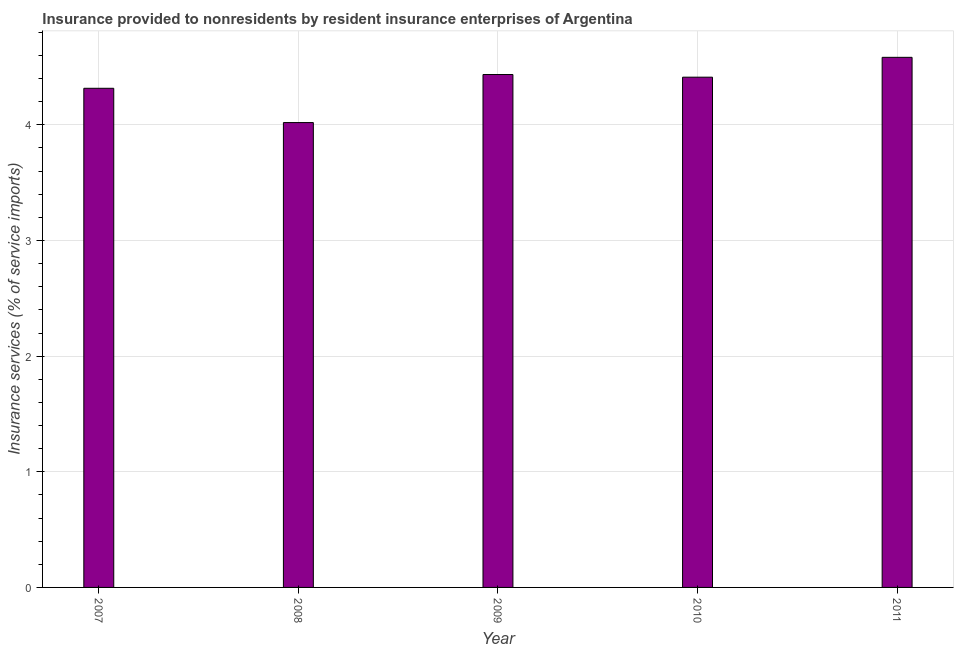Does the graph contain any zero values?
Offer a very short reply. No. What is the title of the graph?
Your answer should be very brief. Insurance provided to nonresidents by resident insurance enterprises of Argentina. What is the label or title of the X-axis?
Provide a succinct answer. Year. What is the label or title of the Y-axis?
Your response must be concise. Insurance services (% of service imports). What is the insurance and financial services in 2011?
Provide a short and direct response. 4.58. Across all years, what is the maximum insurance and financial services?
Give a very brief answer. 4.58. Across all years, what is the minimum insurance and financial services?
Your response must be concise. 4.02. In which year was the insurance and financial services maximum?
Make the answer very short. 2011. What is the sum of the insurance and financial services?
Ensure brevity in your answer.  21.77. What is the difference between the insurance and financial services in 2008 and 2009?
Your response must be concise. -0.42. What is the average insurance and financial services per year?
Keep it short and to the point. 4.35. What is the median insurance and financial services?
Ensure brevity in your answer.  4.41. Do a majority of the years between 2011 and 2010 (inclusive) have insurance and financial services greater than 0.8 %?
Offer a very short reply. No. What is the ratio of the insurance and financial services in 2008 to that in 2010?
Offer a terse response. 0.91. Is the insurance and financial services in 2008 less than that in 2011?
Keep it short and to the point. Yes. Is the difference between the insurance and financial services in 2009 and 2011 greater than the difference between any two years?
Offer a very short reply. No. What is the difference between the highest and the second highest insurance and financial services?
Keep it short and to the point. 0.15. Is the sum of the insurance and financial services in 2007 and 2009 greater than the maximum insurance and financial services across all years?
Ensure brevity in your answer.  Yes. What is the difference between the highest and the lowest insurance and financial services?
Provide a succinct answer. 0.56. Are all the bars in the graph horizontal?
Offer a terse response. No. How many years are there in the graph?
Ensure brevity in your answer.  5. Are the values on the major ticks of Y-axis written in scientific E-notation?
Offer a very short reply. No. What is the Insurance services (% of service imports) in 2007?
Your answer should be very brief. 4.32. What is the Insurance services (% of service imports) in 2008?
Keep it short and to the point. 4.02. What is the Insurance services (% of service imports) in 2009?
Ensure brevity in your answer.  4.44. What is the Insurance services (% of service imports) of 2010?
Ensure brevity in your answer.  4.41. What is the Insurance services (% of service imports) of 2011?
Make the answer very short. 4.58. What is the difference between the Insurance services (% of service imports) in 2007 and 2008?
Give a very brief answer. 0.3. What is the difference between the Insurance services (% of service imports) in 2007 and 2009?
Your answer should be compact. -0.12. What is the difference between the Insurance services (% of service imports) in 2007 and 2010?
Make the answer very short. -0.1. What is the difference between the Insurance services (% of service imports) in 2007 and 2011?
Provide a succinct answer. -0.27. What is the difference between the Insurance services (% of service imports) in 2008 and 2009?
Offer a very short reply. -0.42. What is the difference between the Insurance services (% of service imports) in 2008 and 2010?
Ensure brevity in your answer.  -0.39. What is the difference between the Insurance services (% of service imports) in 2008 and 2011?
Your response must be concise. -0.56. What is the difference between the Insurance services (% of service imports) in 2009 and 2010?
Offer a very short reply. 0.02. What is the difference between the Insurance services (% of service imports) in 2009 and 2011?
Ensure brevity in your answer.  -0.15. What is the difference between the Insurance services (% of service imports) in 2010 and 2011?
Ensure brevity in your answer.  -0.17. What is the ratio of the Insurance services (% of service imports) in 2007 to that in 2008?
Provide a short and direct response. 1.07. What is the ratio of the Insurance services (% of service imports) in 2007 to that in 2011?
Offer a terse response. 0.94. What is the ratio of the Insurance services (% of service imports) in 2008 to that in 2009?
Your response must be concise. 0.91. What is the ratio of the Insurance services (% of service imports) in 2008 to that in 2010?
Give a very brief answer. 0.91. What is the ratio of the Insurance services (% of service imports) in 2008 to that in 2011?
Offer a terse response. 0.88. What is the ratio of the Insurance services (% of service imports) in 2009 to that in 2010?
Your answer should be very brief. 1. 